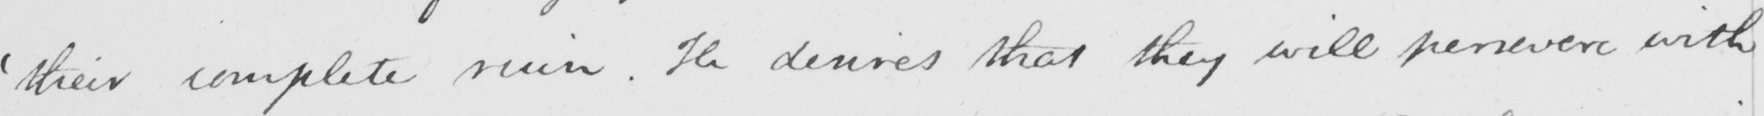Can you read and transcribe this handwriting? ' their complete ruin . He desires that they will persevere with 